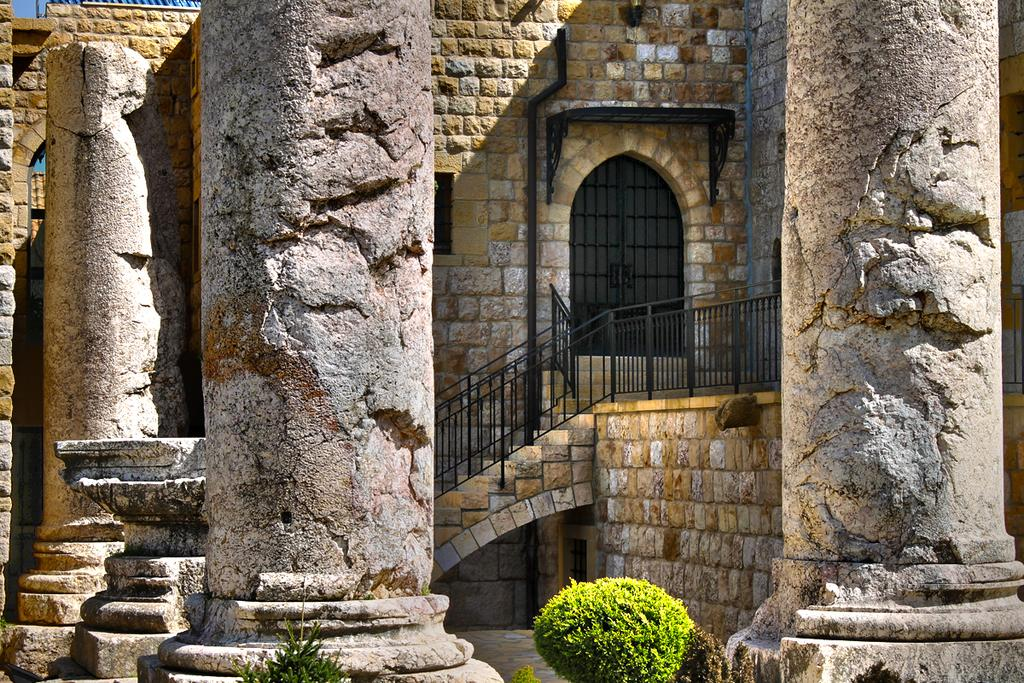What architectural features can be seen in the image? There are pillars in the image. What type of vegetation is near the pillars? There is a bush near the pillars. What can be seen in the background of the image? There is a brick wall, steps with railings, an arch, and a door in the background of the image. What type of horse can be seen near the door in the image? There is no horse present in the image; it only features pillars, a bush, a brick wall, steps with railings, an arch, and a door. 